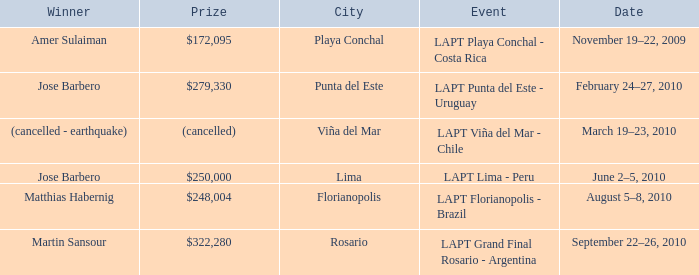What is the date amer sulaiman won? November 19–22, 2009. 